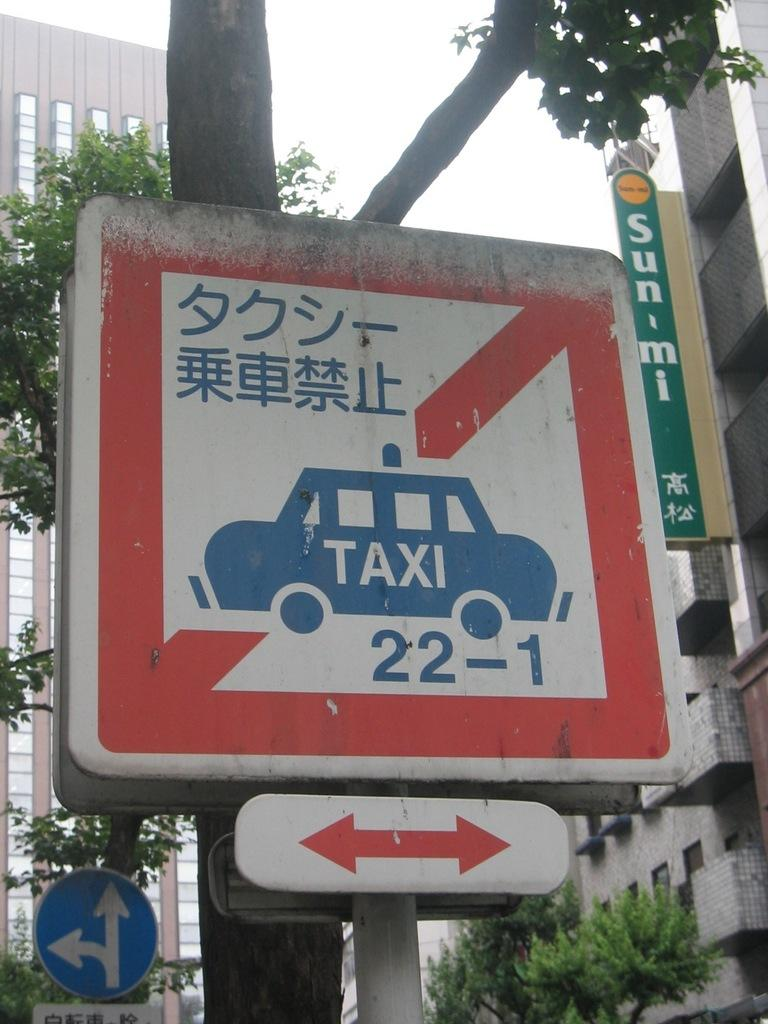What is the main object in the image? There is a pole with sign boards in the image. What can be seen in the background of the image? There is a tree, trees, and buildings in the background of the image. Can you describe the sign board in the image? Yes, there is a sign board in the image. What is visible at the top of the image? The sky is visible at the top of the image. Can you tell me how many bats are hanging from the tree in the image? There are no bats present in the image; it only features a pole with sign boards, a tree, trees, buildings, and the sky. 